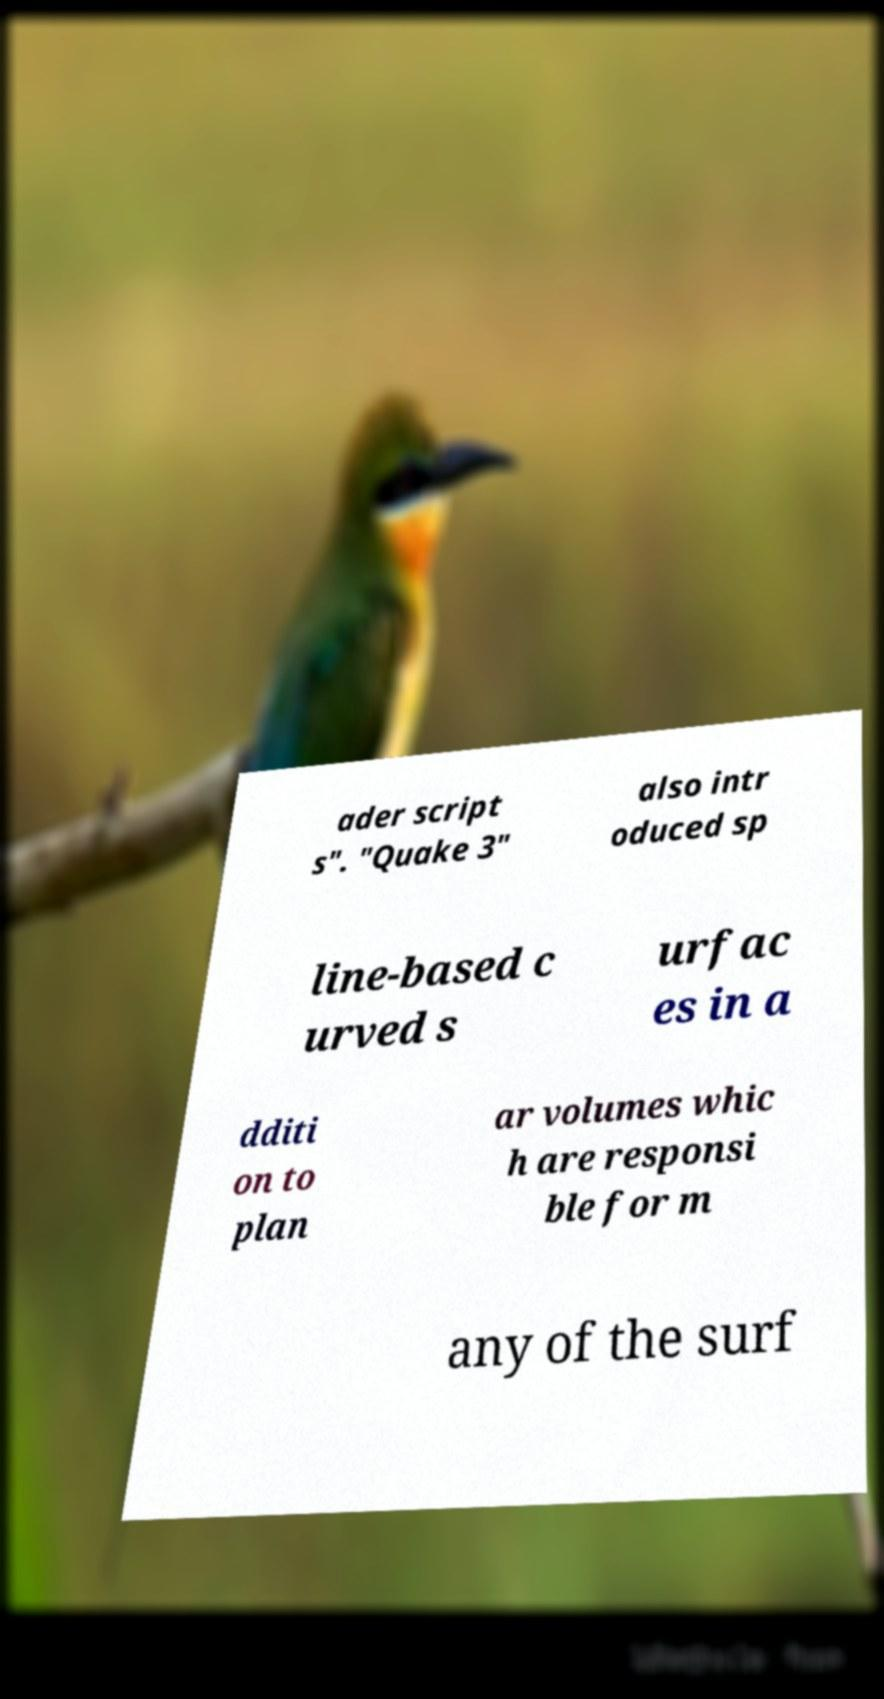Could you extract and type out the text from this image? ader script s". "Quake 3" also intr oduced sp line-based c urved s urfac es in a dditi on to plan ar volumes whic h are responsi ble for m any of the surf 